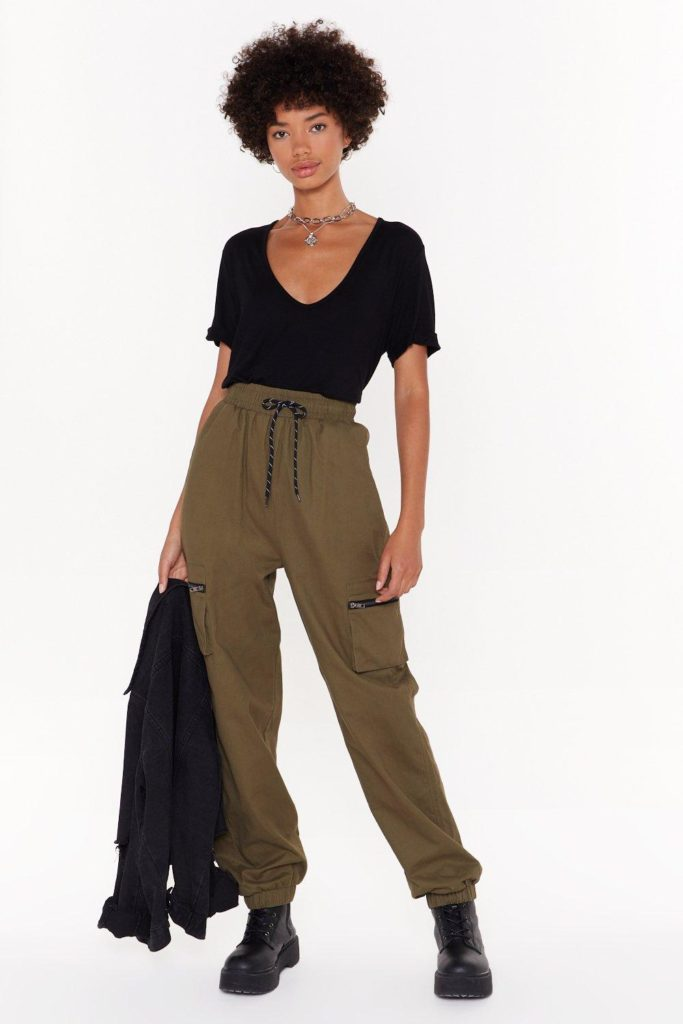Suppose this person is on a fashion magazine cover. What could be the main headline? The main headline could be, 'Urban Chic: Embracing Rugged Elegance'. What articles might be featured in this issue? This issue might feature articles such as '10 Ways to Integrate Utility Wear into Your Wardrobe', 'The Rise of Functional Fashion: Combining Style with Sustainability', 'City Trends Inspired by Nature', and 'Exploring the Connection Between Fashion and Adventure'. It could also include interviews with designers who specialize in blending urban aesthetics with rugged functionality, and photo spreads showcasing outfits that merge comfort with cutting-edge design. 